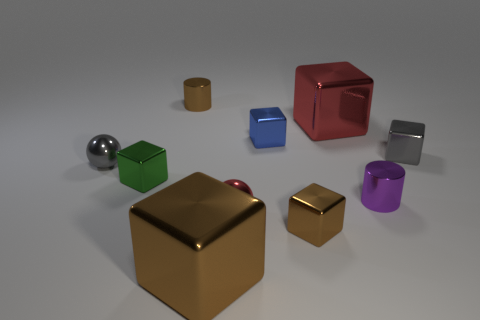There is a red metal object on the left side of the tiny blue metal cube; what number of tiny cubes are left of it?
Keep it short and to the point. 1. What number of objects are either tiny red balls or small things in front of the tiny green shiny block?
Offer a very short reply. 3. Are there any green objects that have the same material as the small brown cube?
Your answer should be very brief. Yes. How many tiny shiny cubes are both in front of the small green metallic thing and to the left of the tiny brown metal cylinder?
Provide a short and direct response. 0. There is a cylinder that is behind the gray shiny ball; what material is it?
Ensure brevity in your answer.  Metal. There is a green object that is made of the same material as the small purple cylinder; what size is it?
Make the answer very short. Small. Are there any small spheres behind the purple object?
Your response must be concise. Yes. What is the size of the brown thing that is the same shape as the tiny purple metal thing?
Offer a terse response. Small. Are there fewer small cylinders than yellow things?
Make the answer very short. No. What number of small brown rubber balls are there?
Keep it short and to the point. 0. 